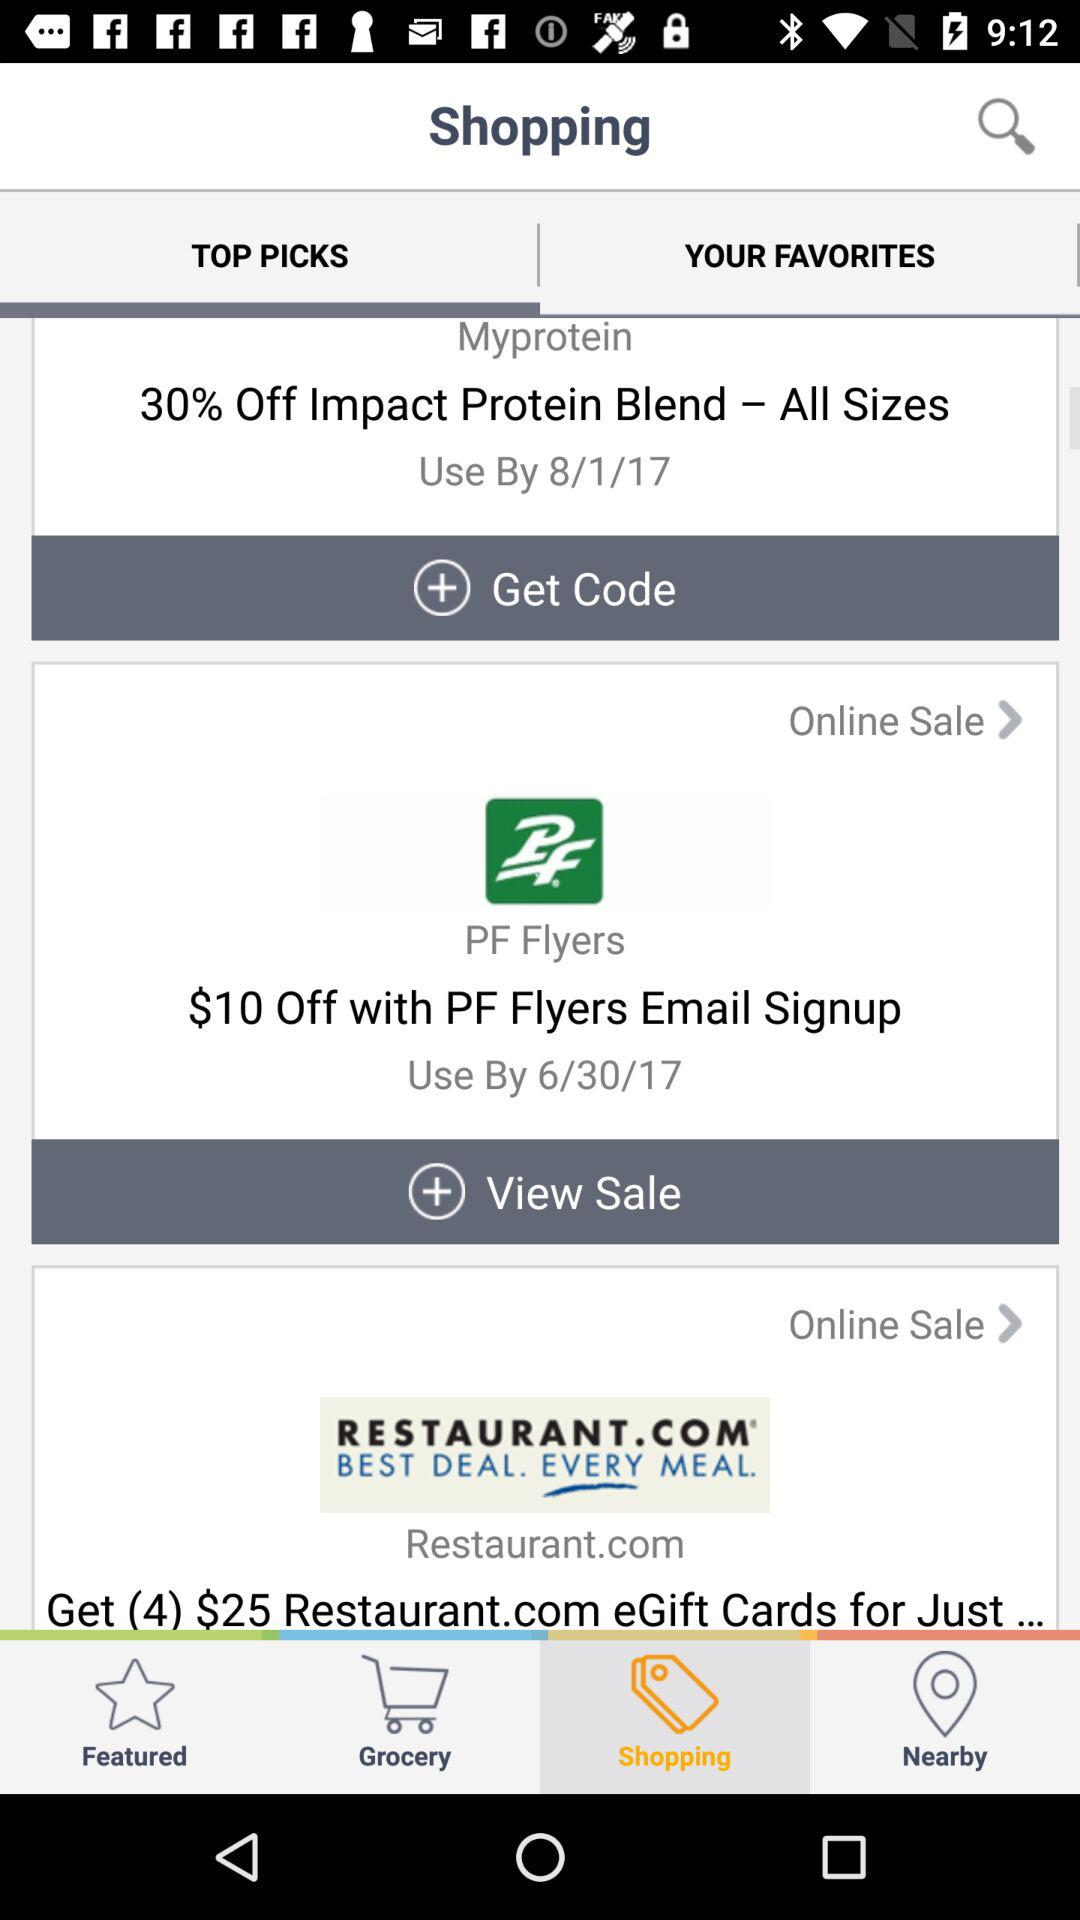What is the discount percentage on "Impact Protein Blend"? The discount percentage is 30. 